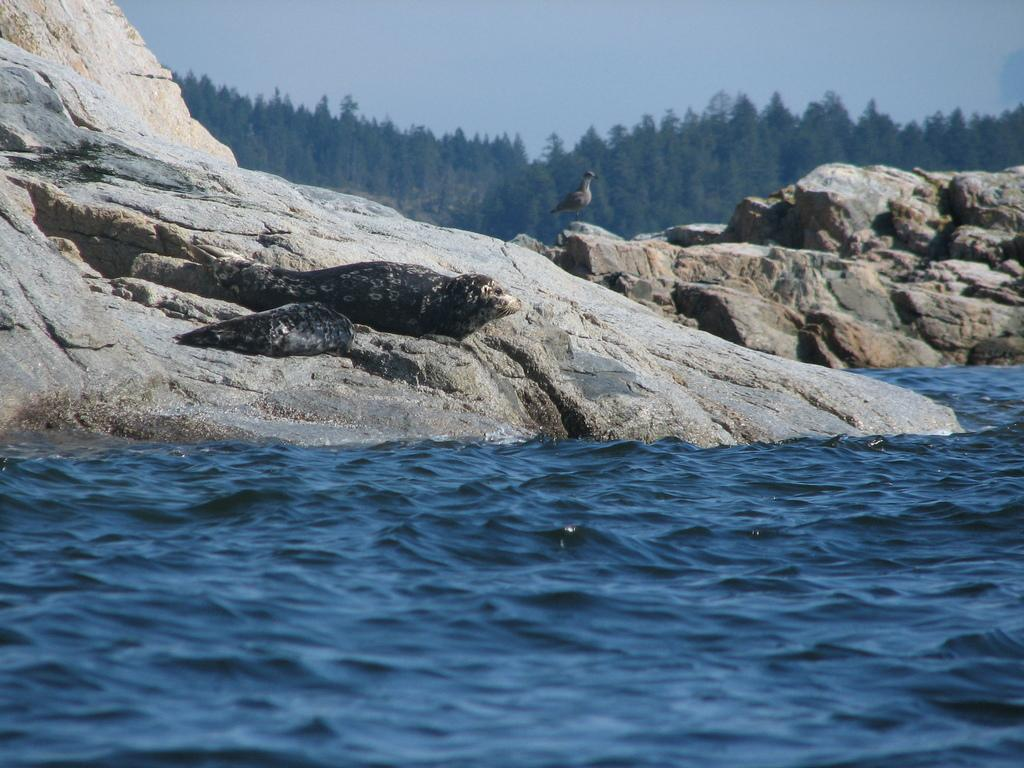What is at the bottom of the image? There is water at the bottom of the image. What other objects can be seen in the image besides water? There are rocks in the image. What is located in the middle of the image? There is a bird in the middle of the image. What type of vegetation is visible in the background of the image? There are trees in the background of the image. What is visible at the top of the image? The sky is visible at the top of the image. How many rings can be seen on the bird's beak in the image? There are no rings visible on the bird's beak in the image. What type of toy is floating in the water at the bottom of the image? There is no toy present in the image; it only features water, rocks, a bird, trees, and the sky. 